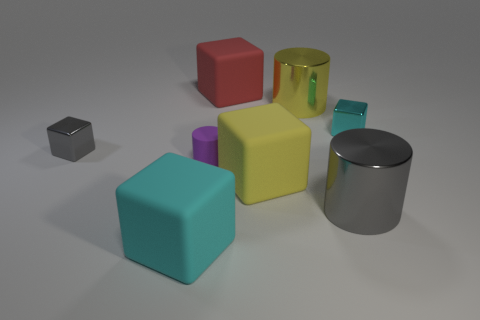Are there any tiny purple metallic cylinders?
Provide a succinct answer. No. There is a cyan object that is in front of the thing to the right of the gray shiny object to the right of the big cyan object; how big is it?
Offer a very short reply. Large. How many other things are the same size as the purple matte object?
Give a very brief answer. 2. How big is the metallic cylinder that is to the left of the gray cylinder?
Your answer should be very brief. Large. Is there anything else of the same color as the rubber cylinder?
Offer a very short reply. No. Are the cube that is behind the cyan metal object and the tiny cyan thing made of the same material?
Make the answer very short. No. How many cubes are both left of the yellow matte block and in front of the matte cylinder?
Give a very brief answer. 1. There is a cyan thing to the left of the small metallic thing behind the gray metallic block; what is its size?
Ensure brevity in your answer.  Large. Are there any other things that have the same material as the tiny cyan block?
Provide a succinct answer. Yes. Is the number of gray things greater than the number of big red matte objects?
Your answer should be very brief. Yes. 